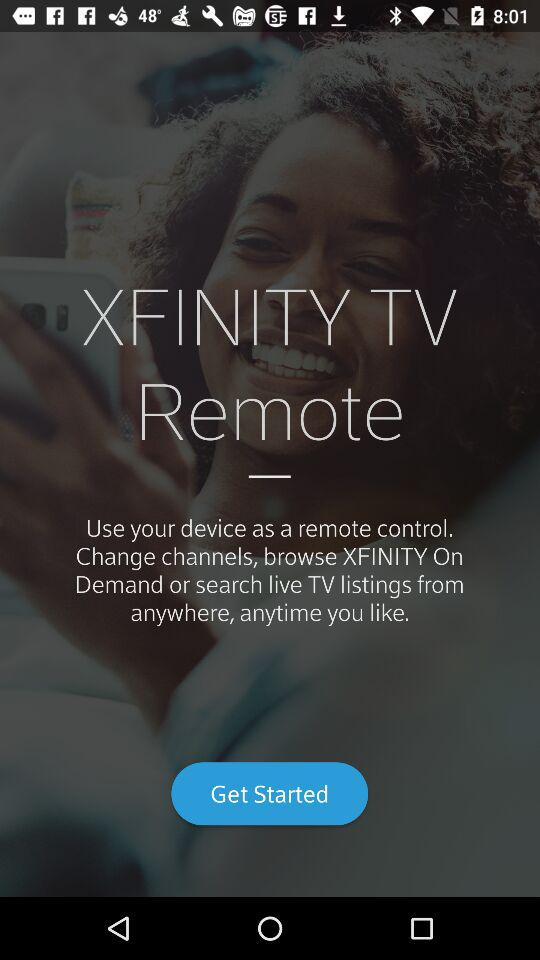What is the name of the application? The application name is "XFINITY TV Remote". 